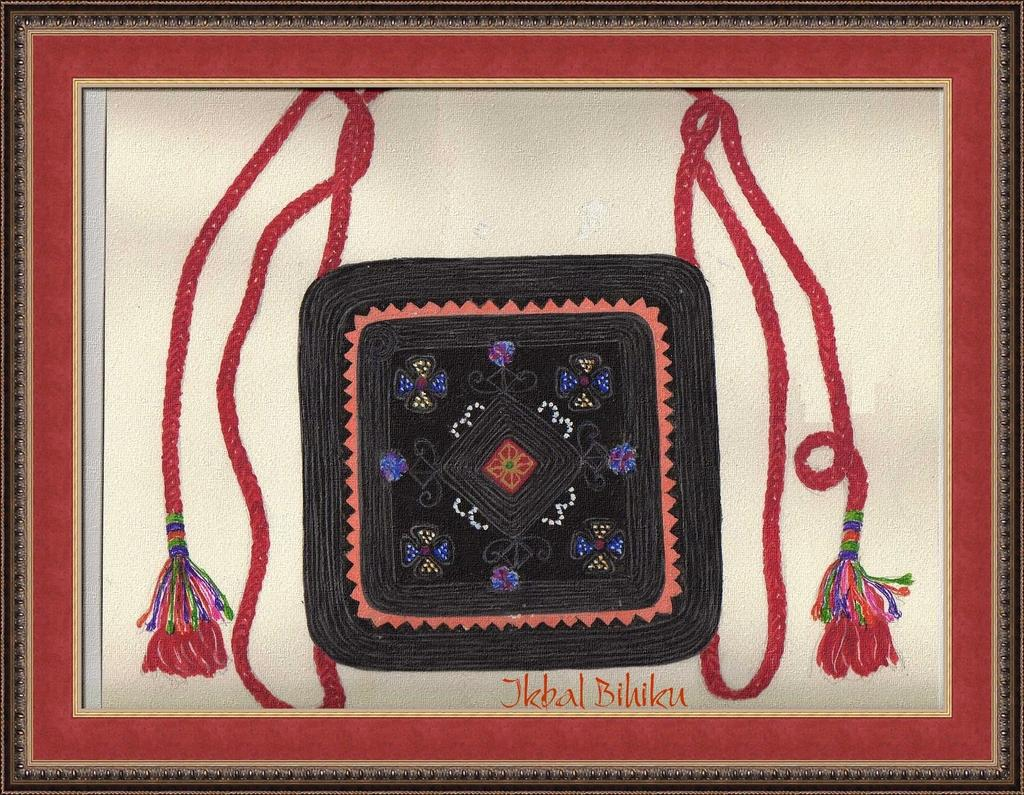What object is present in the image that typically holds a photograph or artwork? There is a photo frame in the image. What is depicted within the photo frame? The photo frame contains an art of a bag. What is the shape of the bag in the photo frame? There is no information provided about the shape of the bag in the photo frame. 